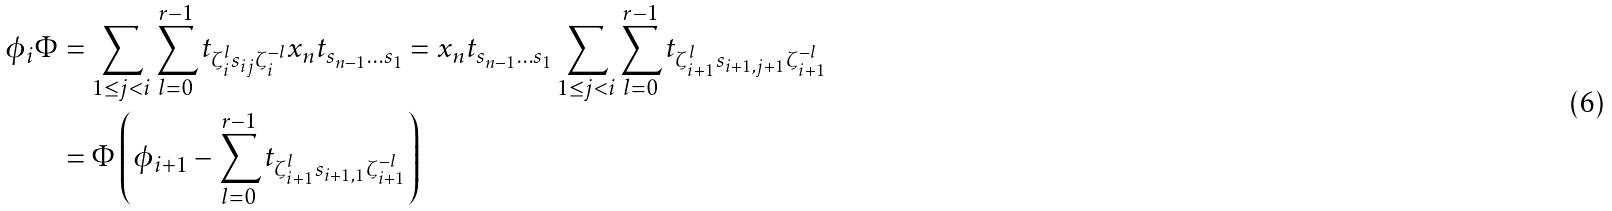Convert formula to latex. <formula><loc_0><loc_0><loc_500><loc_500>\phi _ { i } \Phi & = \sum _ { 1 \leq j < i } \sum _ { l = 0 } ^ { r - 1 } t _ { \zeta _ { i } ^ { l } s _ { i j } \zeta _ { i } ^ { - l } } x _ { n } t _ { s _ { n - 1 } \dots s _ { 1 } } = x _ { n } t _ { s _ { n - 1 } \dots s _ { 1 } } \sum _ { 1 \leq j < i } \sum _ { l = 0 } ^ { r - 1 } t _ { \zeta _ { i + 1 } ^ { l } s _ { i + 1 , j + 1 } \zeta _ { i + 1 } ^ { - l } } \\ & = \Phi \left ( \phi _ { i + 1 } - \sum _ { l = 0 } ^ { r - 1 } t _ { \zeta _ { i + 1 } ^ { l } s _ { i + 1 , 1 } \zeta _ { i + 1 } ^ { - l } } \right )</formula> 